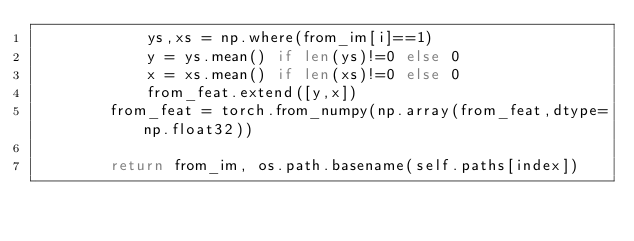<code> <loc_0><loc_0><loc_500><loc_500><_Python_>			ys,xs = np.where(from_im[i]==1)
			y = ys.mean() if len(ys)!=0 else 0
			x = xs.mean() if len(xs)!=0 else 0
			from_feat.extend([y,x])
		from_feat = torch.from_numpy(np.array(from_feat,dtype=np.float32))
		
		return from_im, os.path.basename(self.paths[index])
</code> 